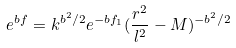<formula> <loc_0><loc_0><loc_500><loc_500>e ^ { b f } = k ^ { b ^ { 2 } / 2 } e ^ { - b f _ { 1 } } ( \frac { r ^ { 2 } } { l ^ { 2 } } - M ) ^ { - b ^ { 2 } / 2 }</formula> 